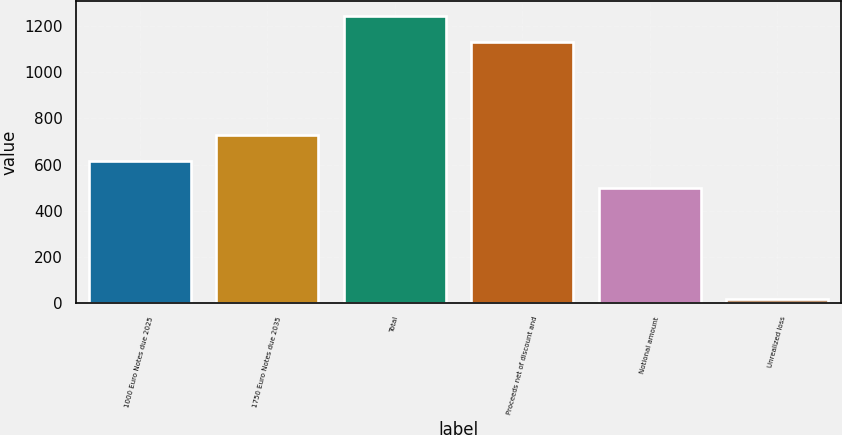Convert chart to OTSL. <chart><loc_0><loc_0><loc_500><loc_500><bar_chart><fcel>1000 Euro Notes due 2025<fcel>1750 Euro Notes due 2035<fcel>Total<fcel>Proceeds net of discount and<fcel>Notional amount<fcel>Unrealized loss<nl><fcel>613.4<fcel>726.8<fcel>1246.4<fcel>1133<fcel>500<fcel>16<nl></chart> 